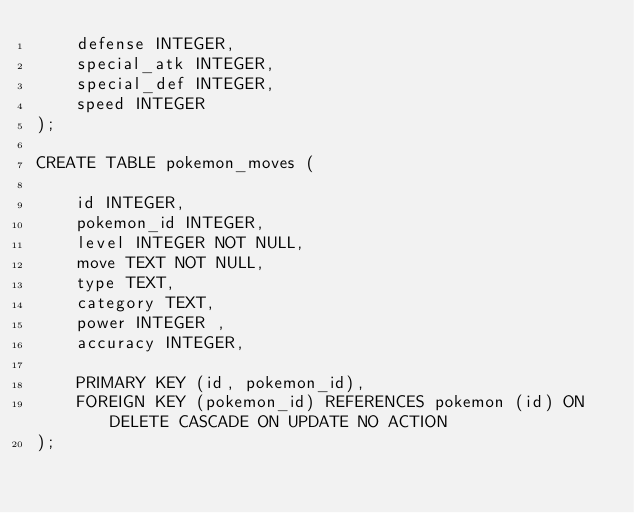Convert code to text. <code><loc_0><loc_0><loc_500><loc_500><_SQL_>	defense INTEGER,
	special_atk INTEGER,
	special_def INTEGER,
	speed INTEGER
);

CREATE TABLE pokemon_moves (
	
	id INTEGER,
	pokemon_id INTEGER,
	level INTEGER NOT NULL,
	move TEXT NOT NULL,
	type TEXT,
	category TEXT,
	power INTEGER ,
	accuracy INTEGER,
	
	PRIMARY KEY (id, pokemon_id),
	FOREIGN KEY (pokemon_id) REFERENCES pokemon (id) ON DELETE CASCADE ON UPDATE NO ACTION
);</code> 